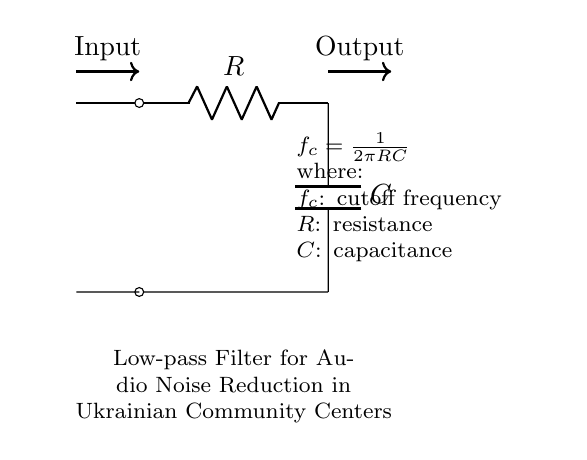What types of components are used in this circuit? The circuit includes a resistor and a capacitor. These are fundamental components in a low-pass filter, where the resistor controls the current and the capacitor stores charge.
Answer: resistor and capacitor What is the purpose of this circuit? The purpose of this circuit is to reduce noise in audio systems by allowing low-frequency signals to pass through while attenuating higher frequencies. This is essential for clearer audio output in community centers.
Answer: reduce audio noise What is the cutoff frequency formula in this filter? The cutoff frequency is calculated using the formula f_c = 1/(2πRC). This formula shows the relationship between the resistance, capacitance, and the frequency at which the output signal begins to fall.
Answer: f_c = 1/(2πRC) How does increasing the resistance affect the cutoff frequency? Increasing the resistance will decrease the cutoff frequency, as f_c is inversely proportional to R in the formula. This means that lower frequencies will pass through while higher frequencies are blocked.
Answer: decreases cutoff frequency What happens to high-frequency signals in this low-pass filter? High-frequency signals are attenuated or reduced in amplitude as they pass through the filter, leading to a clearer low-frequency output. This is the key function of a low-pass filter in audio systems.
Answer: attenuated If the capacitance is doubled, how does it affect the cutoff frequency? Doubling the capacitance will lower the cutoff frequency, as f_c is inversely proportional to C in the formula. This allows even lower frequencies to pass through while blocking more higher frequencies.
Answer: decreases cutoff frequency 